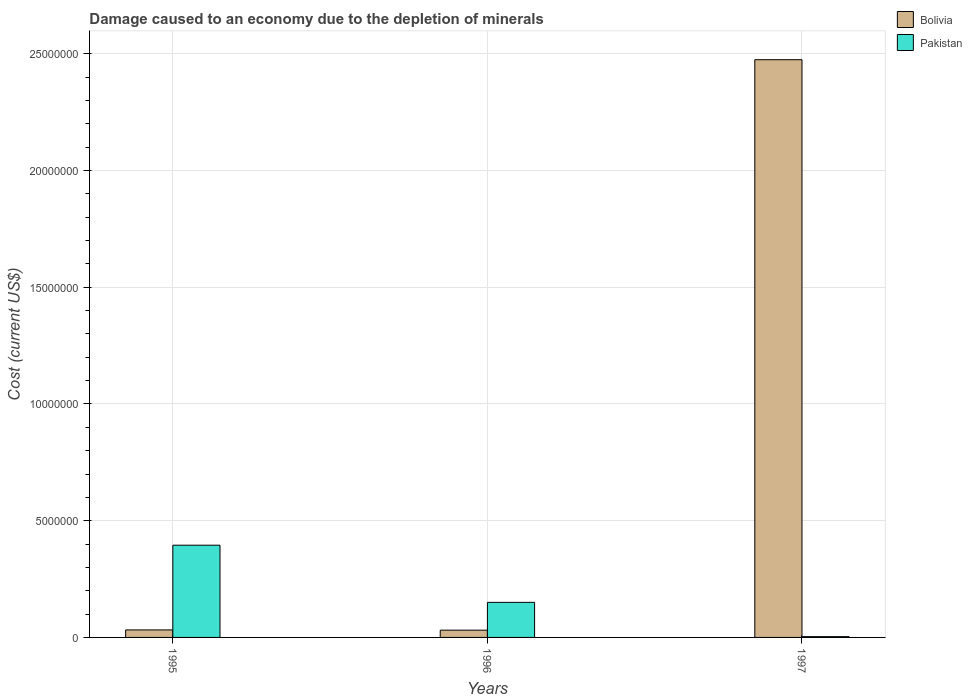How many different coloured bars are there?
Offer a very short reply. 2. How many bars are there on the 2nd tick from the right?
Provide a succinct answer. 2. What is the label of the 2nd group of bars from the left?
Make the answer very short. 1996. What is the cost of damage caused due to the depletion of minerals in Bolivia in 1995?
Provide a succinct answer. 3.22e+05. Across all years, what is the maximum cost of damage caused due to the depletion of minerals in Bolivia?
Your response must be concise. 2.47e+07. Across all years, what is the minimum cost of damage caused due to the depletion of minerals in Bolivia?
Ensure brevity in your answer.  3.11e+05. In which year was the cost of damage caused due to the depletion of minerals in Bolivia maximum?
Make the answer very short. 1997. What is the total cost of damage caused due to the depletion of minerals in Pakistan in the graph?
Make the answer very short. 5.49e+06. What is the difference between the cost of damage caused due to the depletion of minerals in Bolivia in 1996 and that in 1997?
Provide a short and direct response. -2.44e+07. What is the difference between the cost of damage caused due to the depletion of minerals in Pakistan in 1996 and the cost of damage caused due to the depletion of minerals in Bolivia in 1995?
Provide a succinct answer. 1.18e+06. What is the average cost of damage caused due to the depletion of minerals in Bolivia per year?
Provide a short and direct response. 8.46e+06. In the year 1995, what is the difference between the cost of damage caused due to the depletion of minerals in Pakistan and cost of damage caused due to the depletion of minerals in Bolivia?
Give a very brief answer. 3.63e+06. In how many years, is the cost of damage caused due to the depletion of minerals in Bolivia greater than 19000000 US$?
Ensure brevity in your answer.  1. What is the ratio of the cost of damage caused due to the depletion of minerals in Bolivia in 1996 to that in 1997?
Make the answer very short. 0.01. Is the cost of damage caused due to the depletion of minerals in Pakistan in 1995 less than that in 1996?
Ensure brevity in your answer.  No. What is the difference between the highest and the second highest cost of damage caused due to the depletion of minerals in Bolivia?
Provide a short and direct response. 2.44e+07. What is the difference between the highest and the lowest cost of damage caused due to the depletion of minerals in Pakistan?
Give a very brief answer. 3.92e+06. In how many years, is the cost of damage caused due to the depletion of minerals in Pakistan greater than the average cost of damage caused due to the depletion of minerals in Pakistan taken over all years?
Your answer should be very brief. 1. What does the 2nd bar from the left in 1995 represents?
Make the answer very short. Pakistan. What does the 2nd bar from the right in 1997 represents?
Provide a short and direct response. Bolivia. How many bars are there?
Provide a succinct answer. 6. Are all the bars in the graph horizontal?
Offer a terse response. No. What is the title of the graph?
Ensure brevity in your answer.  Damage caused to an economy due to the depletion of minerals. What is the label or title of the X-axis?
Provide a succinct answer. Years. What is the label or title of the Y-axis?
Your response must be concise. Cost (current US$). What is the Cost (current US$) in Bolivia in 1995?
Provide a short and direct response. 3.22e+05. What is the Cost (current US$) in Pakistan in 1995?
Your answer should be compact. 3.95e+06. What is the Cost (current US$) of Bolivia in 1996?
Provide a succinct answer. 3.11e+05. What is the Cost (current US$) of Pakistan in 1996?
Your answer should be compact. 1.50e+06. What is the Cost (current US$) of Bolivia in 1997?
Offer a terse response. 2.47e+07. What is the Cost (current US$) in Pakistan in 1997?
Offer a very short reply. 3.32e+04. Across all years, what is the maximum Cost (current US$) of Bolivia?
Offer a terse response. 2.47e+07. Across all years, what is the maximum Cost (current US$) of Pakistan?
Provide a succinct answer. 3.95e+06. Across all years, what is the minimum Cost (current US$) in Bolivia?
Provide a succinct answer. 3.11e+05. Across all years, what is the minimum Cost (current US$) of Pakistan?
Offer a terse response. 3.32e+04. What is the total Cost (current US$) in Bolivia in the graph?
Give a very brief answer. 2.54e+07. What is the total Cost (current US$) of Pakistan in the graph?
Make the answer very short. 5.49e+06. What is the difference between the Cost (current US$) in Bolivia in 1995 and that in 1996?
Your answer should be very brief. 1.09e+04. What is the difference between the Cost (current US$) of Pakistan in 1995 and that in 1996?
Give a very brief answer. 2.45e+06. What is the difference between the Cost (current US$) in Bolivia in 1995 and that in 1997?
Your answer should be very brief. -2.44e+07. What is the difference between the Cost (current US$) of Pakistan in 1995 and that in 1997?
Make the answer very short. 3.92e+06. What is the difference between the Cost (current US$) of Bolivia in 1996 and that in 1997?
Provide a short and direct response. -2.44e+07. What is the difference between the Cost (current US$) of Pakistan in 1996 and that in 1997?
Your response must be concise. 1.47e+06. What is the difference between the Cost (current US$) of Bolivia in 1995 and the Cost (current US$) of Pakistan in 1996?
Provide a short and direct response. -1.18e+06. What is the difference between the Cost (current US$) in Bolivia in 1995 and the Cost (current US$) in Pakistan in 1997?
Make the answer very short. 2.89e+05. What is the difference between the Cost (current US$) of Bolivia in 1996 and the Cost (current US$) of Pakistan in 1997?
Offer a terse response. 2.78e+05. What is the average Cost (current US$) in Bolivia per year?
Offer a very short reply. 8.46e+06. What is the average Cost (current US$) of Pakistan per year?
Your answer should be compact. 1.83e+06. In the year 1995, what is the difference between the Cost (current US$) in Bolivia and Cost (current US$) in Pakistan?
Provide a short and direct response. -3.63e+06. In the year 1996, what is the difference between the Cost (current US$) in Bolivia and Cost (current US$) in Pakistan?
Your response must be concise. -1.19e+06. In the year 1997, what is the difference between the Cost (current US$) in Bolivia and Cost (current US$) in Pakistan?
Give a very brief answer. 2.47e+07. What is the ratio of the Cost (current US$) of Bolivia in 1995 to that in 1996?
Provide a succinct answer. 1.04. What is the ratio of the Cost (current US$) in Pakistan in 1995 to that in 1996?
Provide a succinct answer. 2.63. What is the ratio of the Cost (current US$) of Bolivia in 1995 to that in 1997?
Keep it short and to the point. 0.01. What is the ratio of the Cost (current US$) of Pakistan in 1995 to that in 1997?
Offer a very short reply. 119.04. What is the ratio of the Cost (current US$) in Bolivia in 1996 to that in 1997?
Provide a short and direct response. 0.01. What is the ratio of the Cost (current US$) in Pakistan in 1996 to that in 1997?
Offer a terse response. 45.26. What is the difference between the highest and the second highest Cost (current US$) of Bolivia?
Offer a very short reply. 2.44e+07. What is the difference between the highest and the second highest Cost (current US$) of Pakistan?
Offer a very short reply. 2.45e+06. What is the difference between the highest and the lowest Cost (current US$) in Bolivia?
Keep it short and to the point. 2.44e+07. What is the difference between the highest and the lowest Cost (current US$) of Pakistan?
Offer a very short reply. 3.92e+06. 